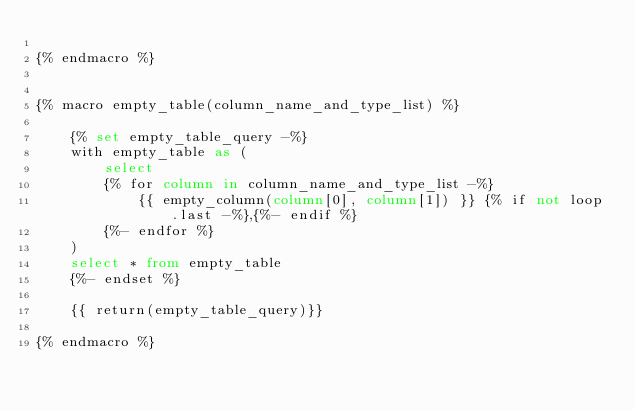<code> <loc_0><loc_0><loc_500><loc_500><_SQL_>
{% endmacro %}


{% macro empty_table(column_name_and_type_list) %}

    {% set empty_table_query -%}
    with empty_table as (
        select
        {% for column in column_name_and_type_list -%}
            {{ empty_column(column[0], column[1]) }} {% if not loop.last -%},{%- endif %}
        {%- endfor %}
    )
    select * from empty_table
    {%- endset %}

    {{ return(empty_table_query)}}

{% endmacro %}</code> 